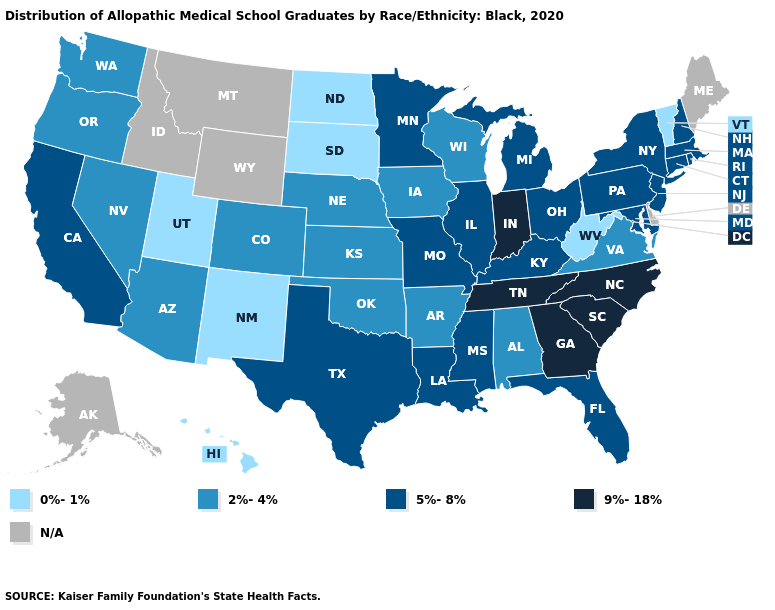What is the value of Alaska?
Short answer required. N/A. Among the states that border Maine , which have the lowest value?
Give a very brief answer. New Hampshire. Name the states that have a value in the range 0%-1%?
Be succinct. Hawaii, New Mexico, North Dakota, South Dakota, Utah, Vermont, West Virginia. Name the states that have a value in the range 2%-4%?
Answer briefly. Alabama, Arizona, Arkansas, Colorado, Iowa, Kansas, Nebraska, Nevada, Oklahoma, Oregon, Virginia, Washington, Wisconsin. What is the value of Arizona?
Give a very brief answer. 2%-4%. How many symbols are there in the legend?
Concise answer only. 5. What is the value of Wisconsin?
Write a very short answer. 2%-4%. Name the states that have a value in the range 0%-1%?
Short answer required. Hawaii, New Mexico, North Dakota, South Dakota, Utah, Vermont, West Virginia. What is the lowest value in the USA?
Be succinct. 0%-1%. Name the states that have a value in the range 0%-1%?
Give a very brief answer. Hawaii, New Mexico, North Dakota, South Dakota, Utah, Vermont, West Virginia. Name the states that have a value in the range N/A?
Write a very short answer. Alaska, Delaware, Idaho, Maine, Montana, Wyoming. Name the states that have a value in the range 9%-18%?
Write a very short answer. Georgia, Indiana, North Carolina, South Carolina, Tennessee. Name the states that have a value in the range 2%-4%?
Write a very short answer. Alabama, Arizona, Arkansas, Colorado, Iowa, Kansas, Nebraska, Nevada, Oklahoma, Oregon, Virginia, Washington, Wisconsin. 